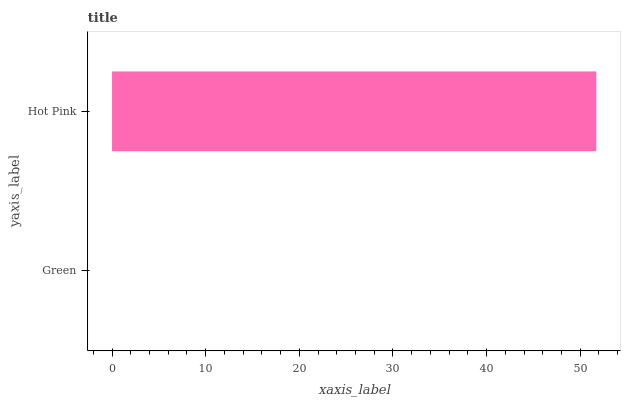Is Green the minimum?
Answer yes or no. Yes. Is Hot Pink the maximum?
Answer yes or no. Yes. Is Hot Pink the minimum?
Answer yes or no. No. Is Hot Pink greater than Green?
Answer yes or no. Yes. Is Green less than Hot Pink?
Answer yes or no. Yes. Is Green greater than Hot Pink?
Answer yes or no. No. Is Hot Pink less than Green?
Answer yes or no. No. Is Hot Pink the high median?
Answer yes or no. Yes. Is Green the low median?
Answer yes or no. Yes. Is Green the high median?
Answer yes or no. No. Is Hot Pink the low median?
Answer yes or no. No. 